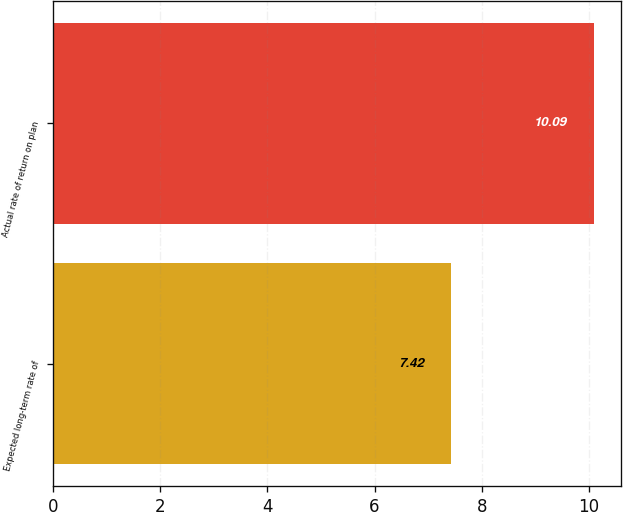Convert chart to OTSL. <chart><loc_0><loc_0><loc_500><loc_500><bar_chart><fcel>Expected long-term rate of<fcel>Actual rate of return on plan<nl><fcel>7.42<fcel>10.09<nl></chart> 